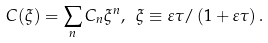Convert formula to latex. <formula><loc_0><loc_0><loc_500><loc_500>C ( \xi ) = \sum _ { n } C _ { n } \xi ^ { n } , \ \xi \equiv \varepsilon \tau / \left ( 1 + \varepsilon \tau \right ) .</formula> 